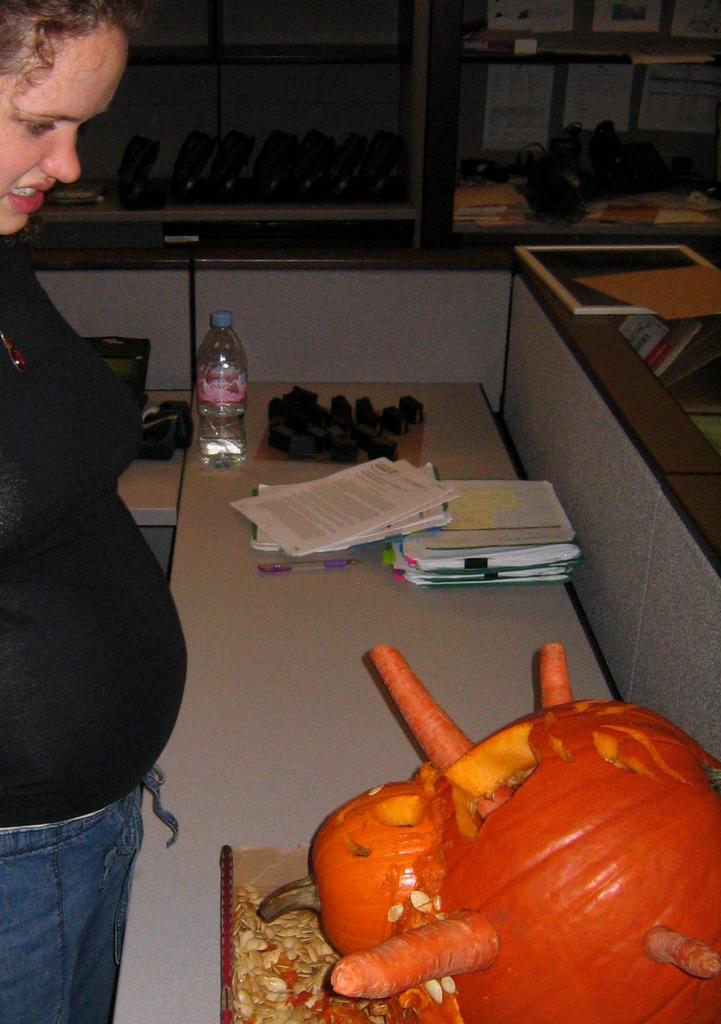Could you give a brief overview of what you see in this image? In this picture we can see a woman in the black t shirt is standing and in front of the woman there is a desk and on the desk there is a pumpkin, papers, pen and other things. Behind the women there are some other things in the racks. 